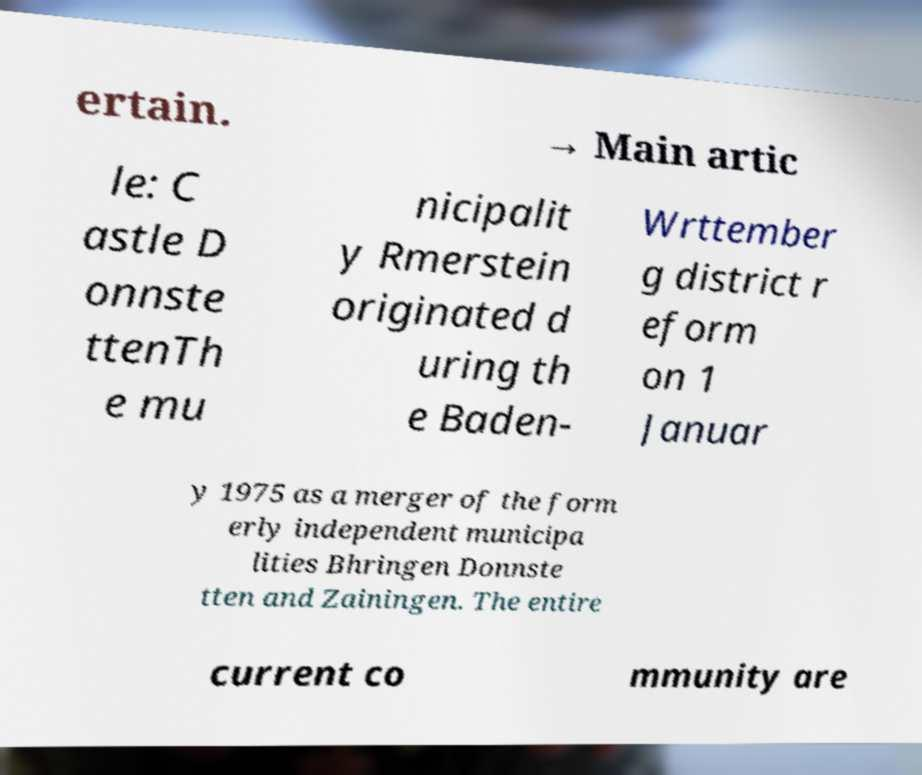Can you accurately transcribe the text from the provided image for me? ertain. → Main artic le: C astle D onnste ttenTh e mu nicipalit y Rmerstein originated d uring th e Baden- Wrttember g district r eform on 1 Januar y 1975 as a merger of the form erly independent municipa lities Bhringen Donnste tten and Zainingen. The entire current co mmunity are 